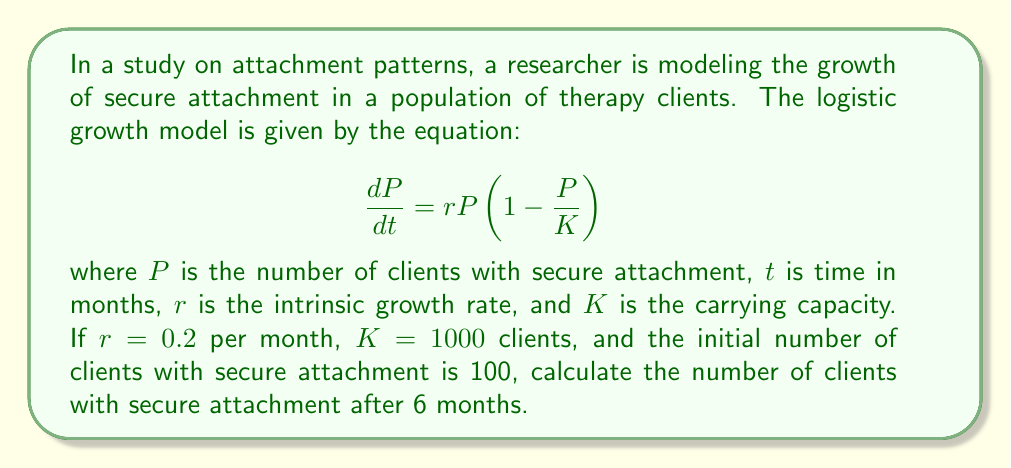Show me your answer to this math problem. To solve this problem, we need to use the solution to the logistic growth equation:

$$P(t) = \frac{K}{1 + (\frac{K}{P_0} - 1)e^{-rt}}$$

Where:
$P(t)$ is the population size at time $t$
$K$ is the carrying capacity
$P_0$ is the initial population size
$r$ is the intrinsic growth rate
$t$ is the time

Given:
$K = 1000$ clients
$P_0 = 100$ clients
$r = 0.2$ per month
$t = 6$ months

Let's substitute these values into the equation:

$$P(6) = \frac{1000}{1 + (\frac{1000}{100} - 1)e^{-0.2 \cdot 6}}$$

$$= \frac{1000}{1 + (10 - 1)e^{-1.2}}$$

$$= \frac{1000}{1 + 9e^{-1.2}}$$

Now, let's calculate $e^{-1.2}$:

$e^{-1.2} \approx 0.301194$

Substituting this value:

$$P(6) = \frac{1000}{1 + 9 \cdot 0.301194}$$

$$= \frac{1000}{1 + 2.710746}$$

$$= \frac{1000}{3.710746}$$

$$\approx 269.49$$

Rounding to the nearest whole number, as we're dealing with people:

$P(6) \approx 269$ clients
Answer: After 6 months, there will be approximately 269 clients with secure attachment. 